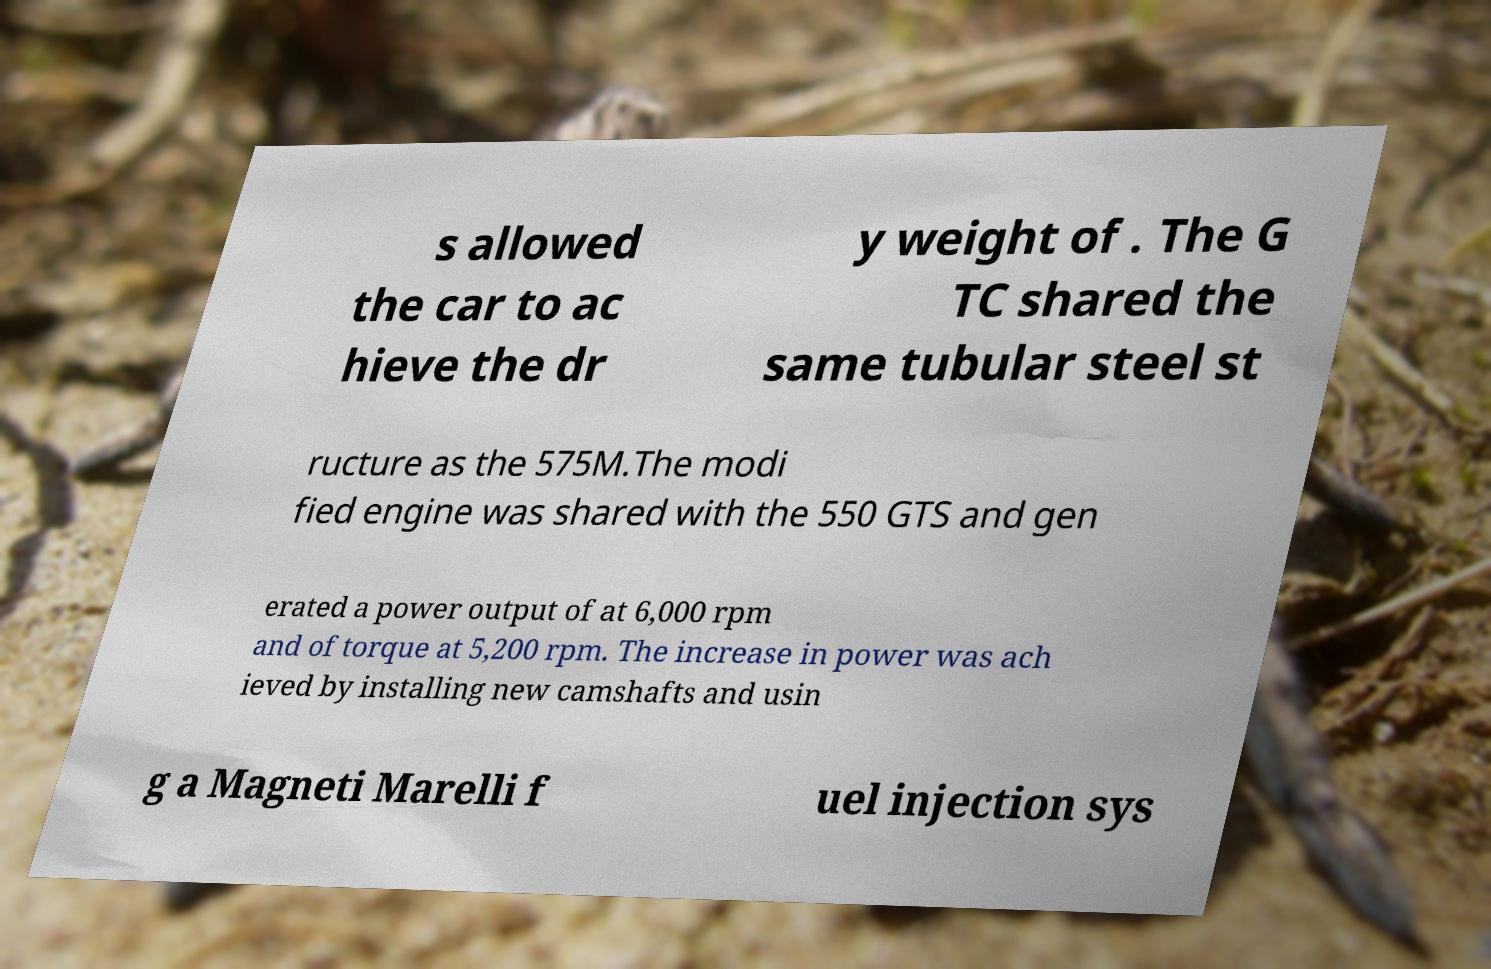There's text embedded in this image that I need extracted. Can you transcribe it verbatim? s allowed the car to ac hieve the dr y weight of . The G TC shared the same tubular steel st ructure as the 575M.The modi fied engine was shared with the 550 GTS and gen erated a power output of at 6,000 rpm and of torque at 5,200 rpm. The increase in power was ach ieved by installing new camshafts and usin g a Magneti Marelli f uel injection sys 